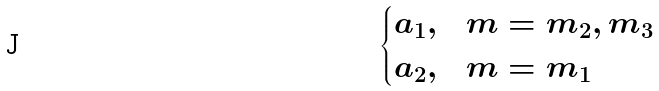Convert formula to latex. <formula><loc_0><loc_0><loc_500><loc_500>\begin{cases} a _ { 1 } , & m = m _ { 2 } , m _ { 3 } \\ a _ { 2 } , & m = m _ { 1 } \end{cases}</formula> 